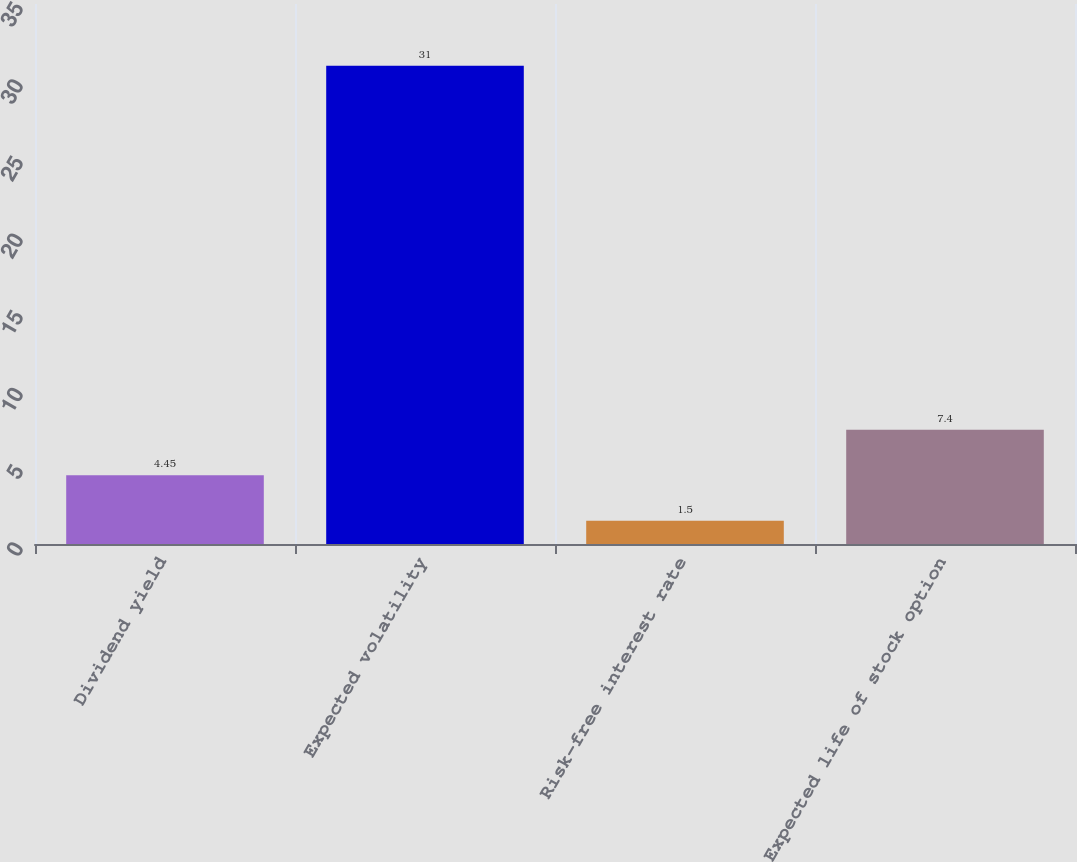Convert chart to OTSL. <chart><loc_0><loc_0><loc_500><loc_500><bar_chart><fcel>Dividend yield<fcel>Expected volatility<fcel>Risk-free interest rate<fcel>Expected life of stock option<nl><fcel>4.45<fcel>31<fcel>1.5<fcel>7.4<nl></chart> 